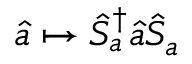Convert formula to latex. <formula><loc_0><loc_0><loc_500><loc_500>\hat { a } \mapsto \hat { S } _ { a } ^ { \dagger } \hat { a } \hat { S } _ { a }</formula> 